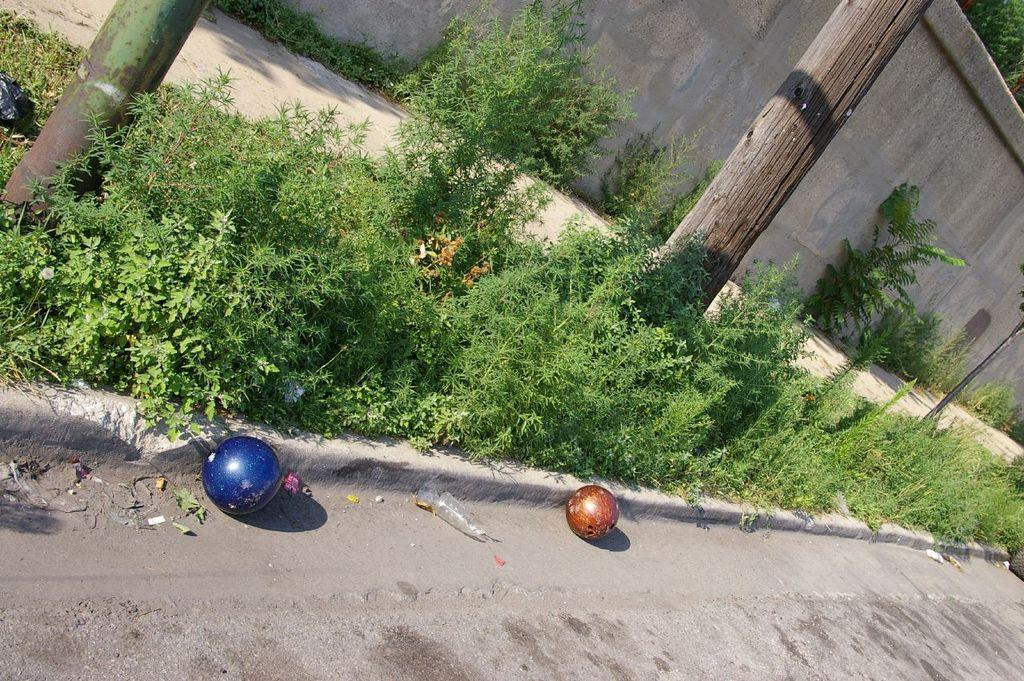What type of vegetation can be seen in the image? There are plants and trees in the image. What type of structure is visible in the image? There is a wall in the image. What type of vertical structure is visible in the image? There is a pole in the image. What type of pathway is visible in the image? There is a road in the image. What is present on the road in the image? There are objects on the road in the image. What type of company is visible in the image? There is no company present in the image. Is there a bridge visible in the image? No, there is no bridge present in the image. 